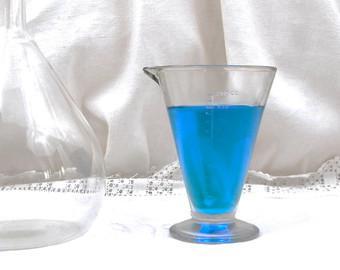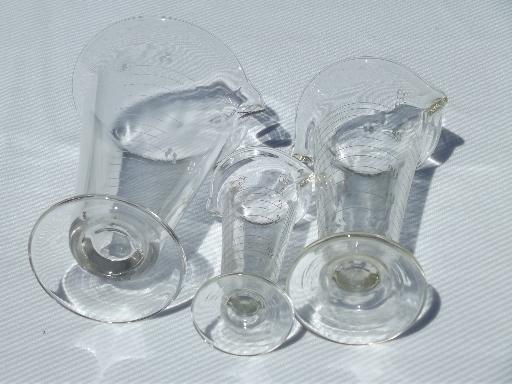The first image is the image on the left, the second image is the image on the right. Evaluate the accuracy of this statement regarding the images: "The left and right image contains the same number of beakers.". Is it true? Answer yes or no. No. 